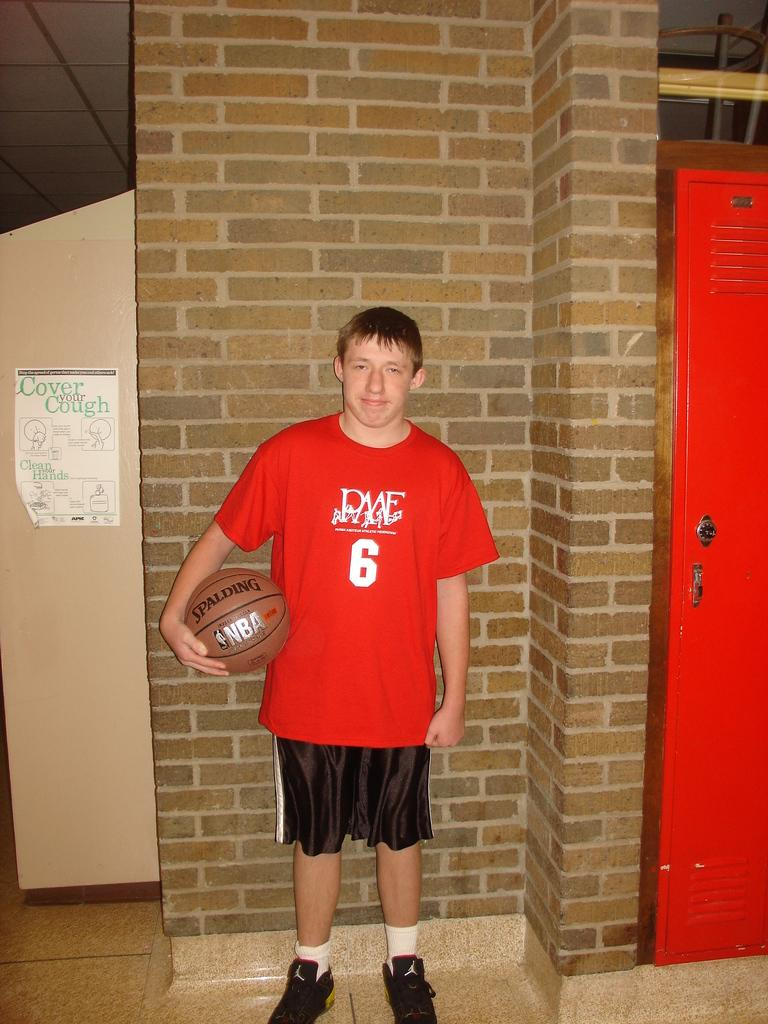<image>
Give a short and clear explanation of the subsequent image. A boy stands in front of a sign that Says Cover Your Cough! 